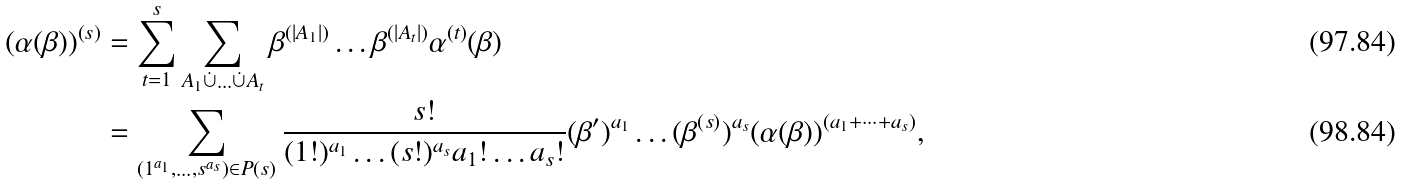Convert formula to latex. <formula><loc_0><loc_0><loc_500><loc_500>( \alpha ( \beta ) ) ^ { ( s ) } & = \sum _ { t = 1 } ^ { s } \sum _ { A _ { 1 } \dot { \cup } \dots \dot { \cup } A _ { t } } \beta ^ { ( | A _ { 1 } | ) } \dots \beta ^ { ( | A _ { t } | ) } \alpha ^ { ( t ) } ( \beta ) \\ & = \sum _ { ( 1 ^ { a _ { 1 } } , \dots , s ^ { a _ { s } } ) \in P ( s ) } \frac { s ! } { ( 1 ! ) ^ { a _ { 1 } } \dots ( s ! ) ^ { a _ { s } } a _ { 1 } ! \dots a _ { s } ! } ( \beta ^ { \prime } ) ^ { a _ { 1 } } \dots ( \beta ^ { ( s ) } ) ^ { a _ { s } } ( \alpha ( \beta ) ) ^ { ( a _ { 1 } + \dots + a _ { s } ) } ,</formula> 